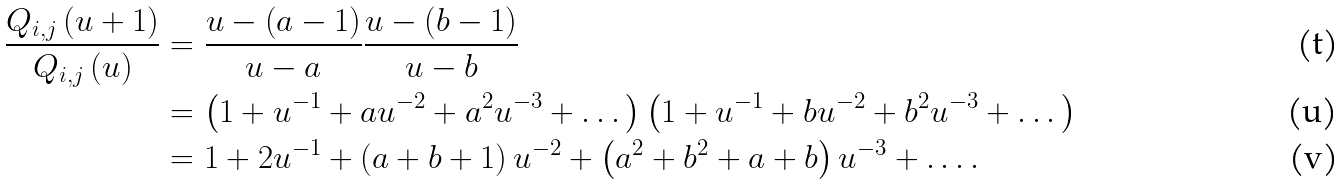<formula> <loc_0><loc_0><loc_500><loc_500>\frac { Q _ { i , j } \left ( u + 1 \right ) } { Q _ { i , j } \left ( u \right ) } & = \frac { u - \left ( a - 1 \right ) } { u - a } \frac { u - \left ( b - 1 \right ) } { u - b } \\ & = \left ( 1 + u ^ { - 1 } + a u ^ { - 2 } + a ^ { 2 } u ^ { - 3 } + \dots \right ) \left ( 1 + u ^ { - 1 } + b u ^ { - 2 } + b ^ { 2 } u ^ { - 3 } + \dots \right ) \\ & = 1 + 2 u ^ { - 1 } + \left ( a + b + 1 \right ) u ^ { - 2 } + \left ( a ^ { 2 } + b ^ { 2 } + a + b \right ) u ^ { - 3 } + \dots .</formula> 